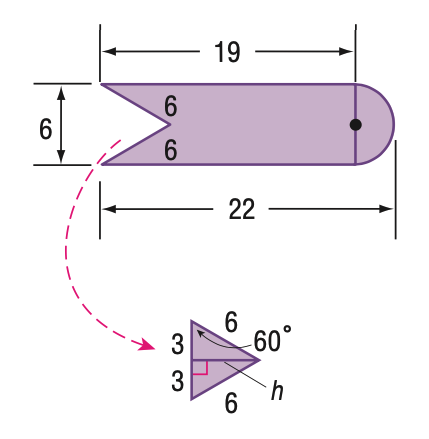Answer the mathemtical geometry problem and directly provide the correct option letter.
Question: Find the area of the figure.
Choices: A: 98.4 B: 112.5 C: 114 D: 128.1 B 